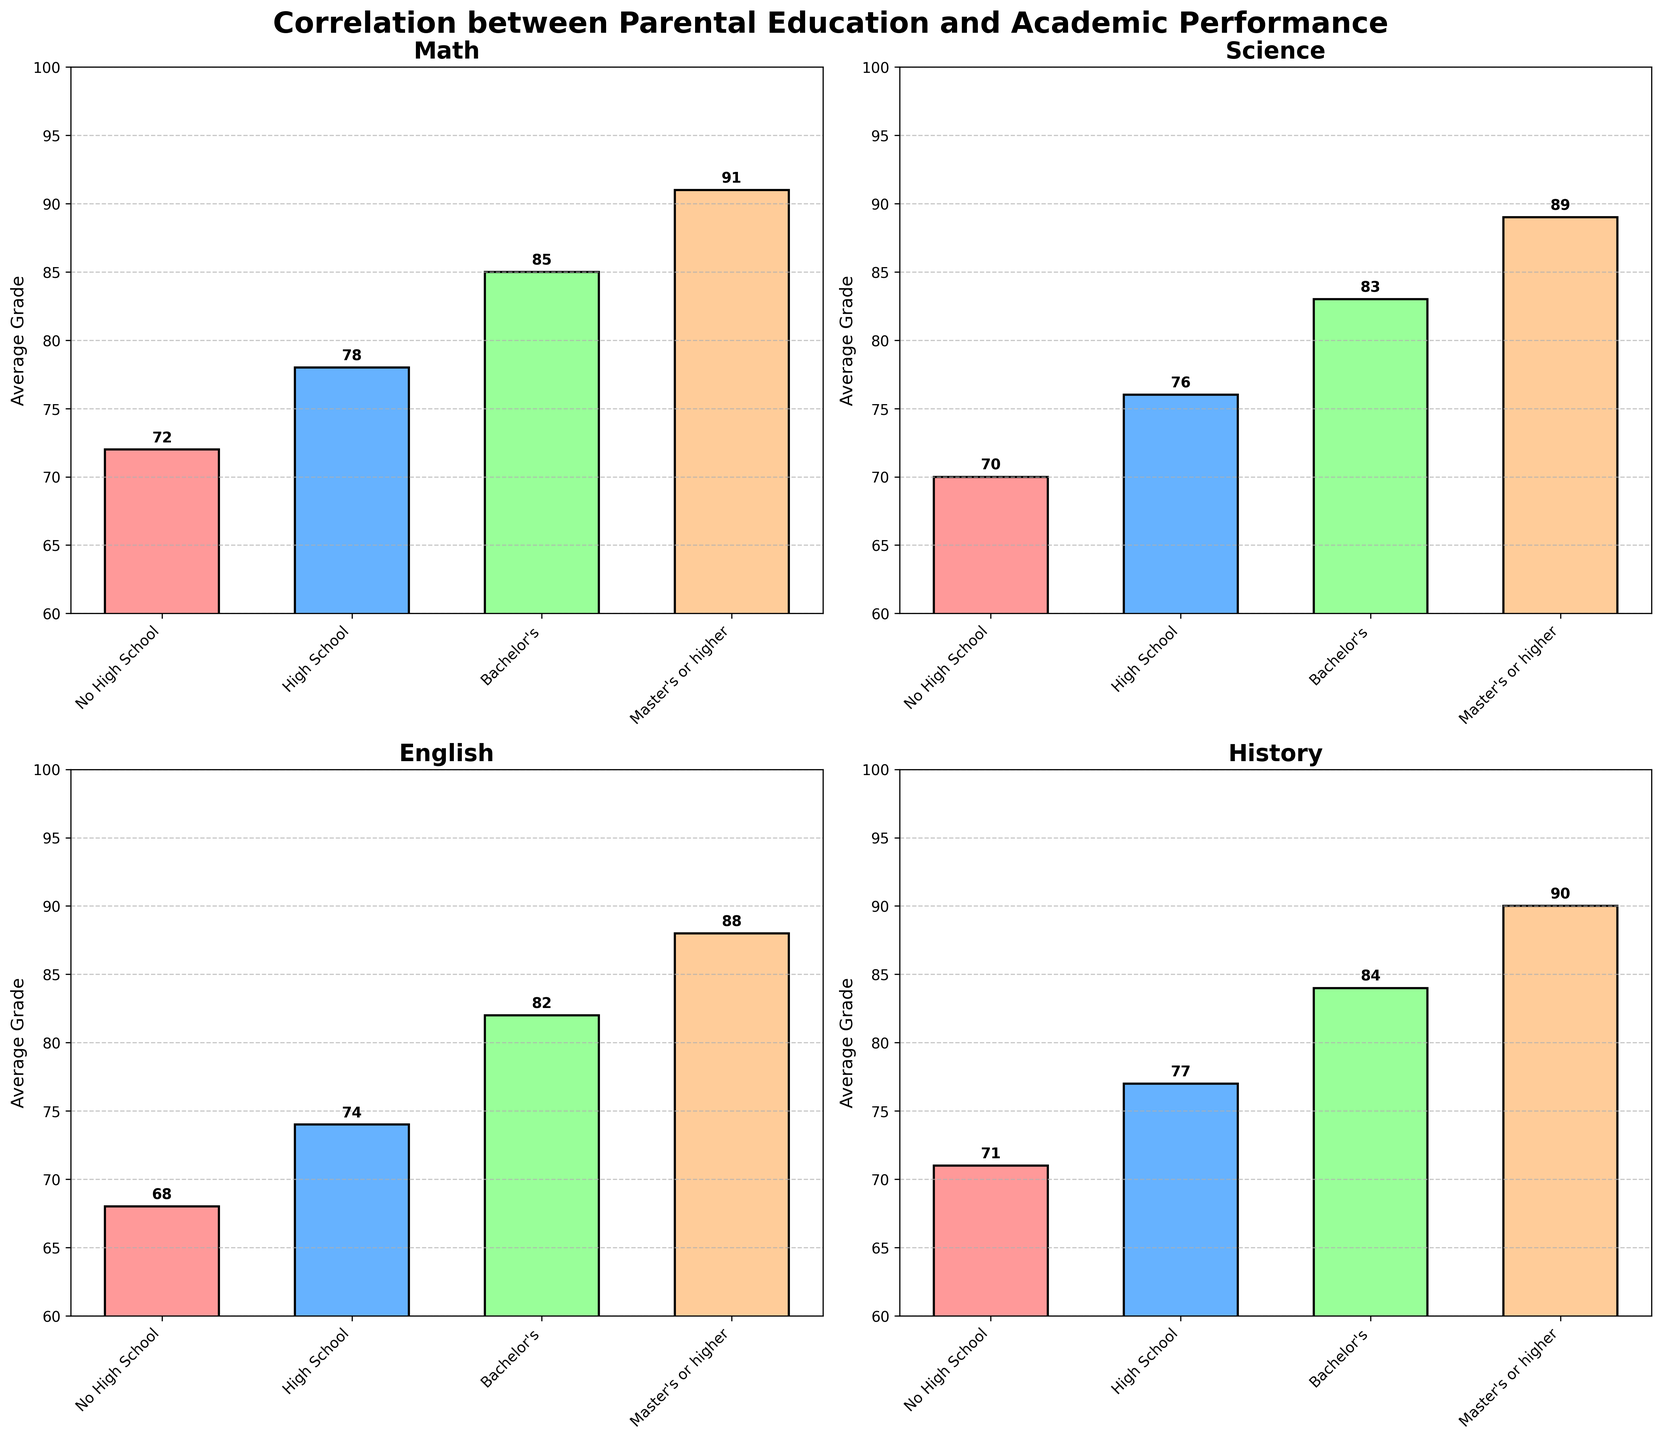What's the title of the figure? The title is located at the top of the figure in a larger, bold font.
Answer: Correlation between Parental Education and Academic Performance What is the average grade for Math students whose parents have a Bachelor's degree? Looking at the Math subplot, find the bar corresponding to "Bachelor's" on the x-axis and read the height of the bar.
Answer: 85 How does the average grade in Science compare between students whose parents have Master's degrees and those whose parents have a high school education? Look at the Science subplot. Find the heights of the bars labeled "Master's or higher" and "High School." The height of the bar for "Master's or higher" is 89, and for "High School" it is 76.
Answer: Students with parents having a Master's degree have an average grade 13 points higher than those with high school-educated parents Which subject shows the smallest increase in average grade from "No High School" to "Master's or higher" parental education? Calculate the difference between the average grades for "Master's or higher" and "No High School" for each subject. The differences are: Math (19), Science (19), English (20), History (19). The smallest difference is for Math, Science, and History.
Answer: Math, Science, History What's the color of the bars in the English subplot? The color of the bars in the English subplot can be identified by looking at the colors of the bars in that subplot.
Answer: #99FF99 In which subject do students with parents holding a Bachelor's degree perform worse compared to the others? Compare the average grade for students with parents holding a Bachelor's degree across all subplots. The grades are: Math (85), Science (83), English (82), History (84). The lowest is in English.
Answer: English What is the average grade difference between Math and History for students whose parents did not finish high school? Look at the Math and History subplots and find the bars corresponding to "No High School." The heights are 72 for Math and 71 for History. The difference is 72 - 71.
Answer: 1 What is the layout of the subplots? The layout can be identified from how the subplots are arranged in the figure. There are four subplots organized in a grid-like structure.
Answer: 2x2 grid 